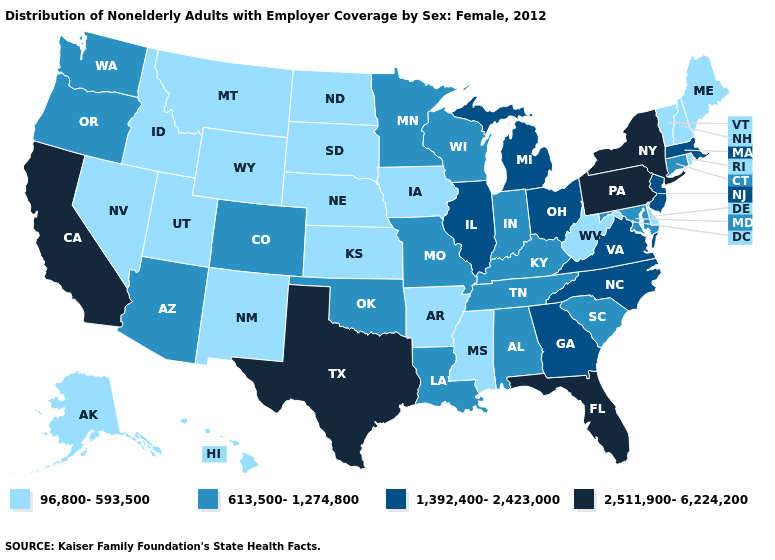Which states have the lowest value in the West?
Quick response, please. Alaska, Hawaii, Idaho, Montana, Nevada, New Mexico, Utah, Wyoming. What is the value of Virginia?
Write a very short answer. 1,392,400-2,423,000. Among the states that border Idaho , which have the lowest value?
Give a very brief answer. Montana, Nevada, Utah, Wyoming. What is the lowest value in the USA?
Concise answer only. 96,800-593,500. What is the value of New Mexico?
Be succinct. 96,800-593,500. What is the lowest value in the USA?
Write a very short answer. 96,800-593,500. What is the value of Indiana?
Keep it brief. 613,500-1,274,800. Does the map have missing data?
Write a very short answer. No. Does Maryland have the lowest value in the South?
Quick response, please. No. Does Colorado have the same value as New Mexico?
Be succinct. No. Name the states that have a value in the range 96,800-593,500?
Keep it brief. Alaska, Arkansas, Delaware, Hawaii, Idaho, Iowa, Kansas, Maine, Mississippi, Montana, Nebraska, Nevada, New Hampshire, New Mexico, North Dakota, Rhode Island, South Dakota, Utah, Vermont, West Virginia, Wyoming. Name the states that have a value in the range 2,511,900-6,224,200?
Short answer required. California, Florida, New York, Pennsylvania, Texas. What is the value of West Virginia?
Answer briefly. 96,800-593,500. Name the states that have a value in the range 96,800-593,500?
Concise answer only. Alaska, Arkansas, Delaware, Hawaii, Idaho, Iowa, Kansas, Maine, Mississippi, Montana, Nebraska, Nevada, New Hampshire, New Mexico, North Dakota, Rhode Island, South Dakota, Utah, Vermont, West Virginia, Wyoming. What is the lowest value in the USA?
Concise answer only. 96,800-593,500. 